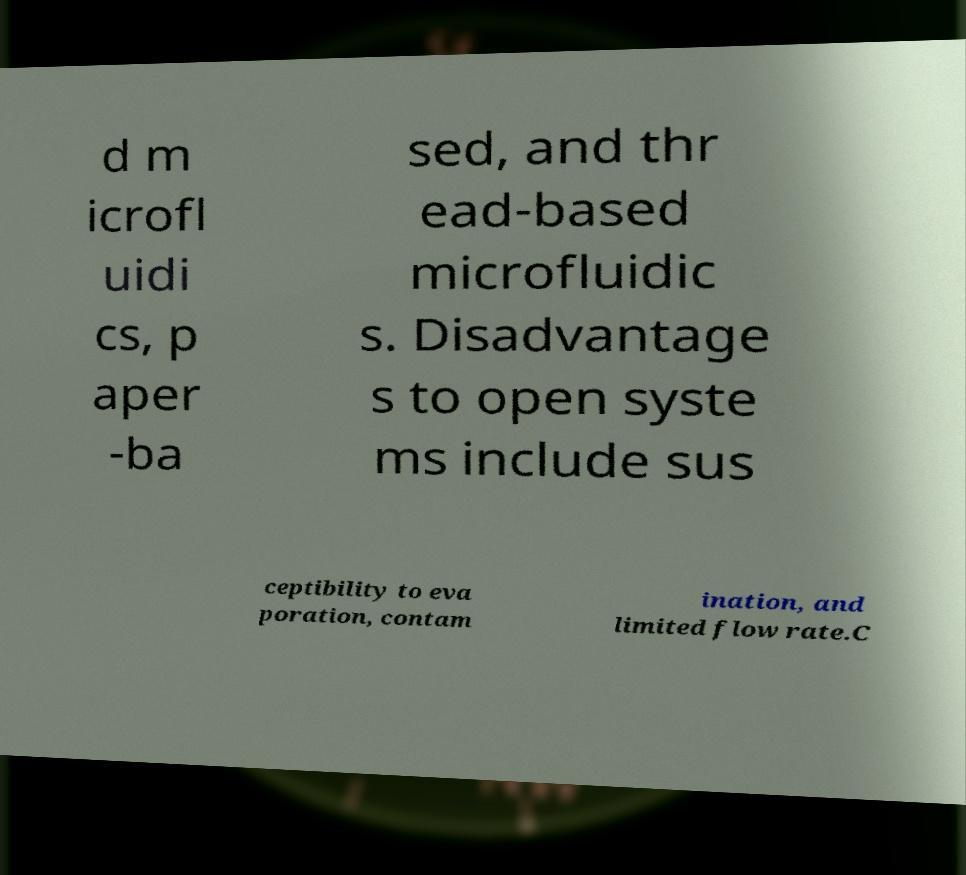Can you accurately transcribe the text from the provided image for me? d m icrofl uidi cs, p aper -ba sed, and thr ead-based microfluidic s. Disadvantage s to open syste ms include sus ceptibility to eva poration, contam ination, and limited flow rate.C 